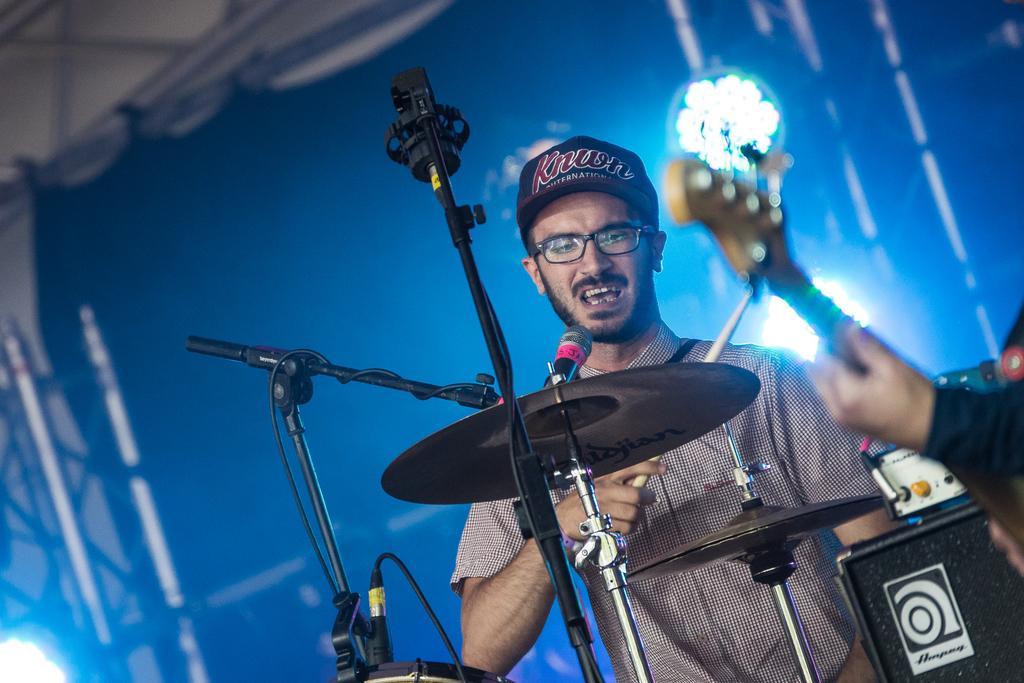Please provide a concise description of this image. In this picture I can see 2 persons in front and I see the musical instruments and in the background I see the lights and I can also see the tripods in front. 